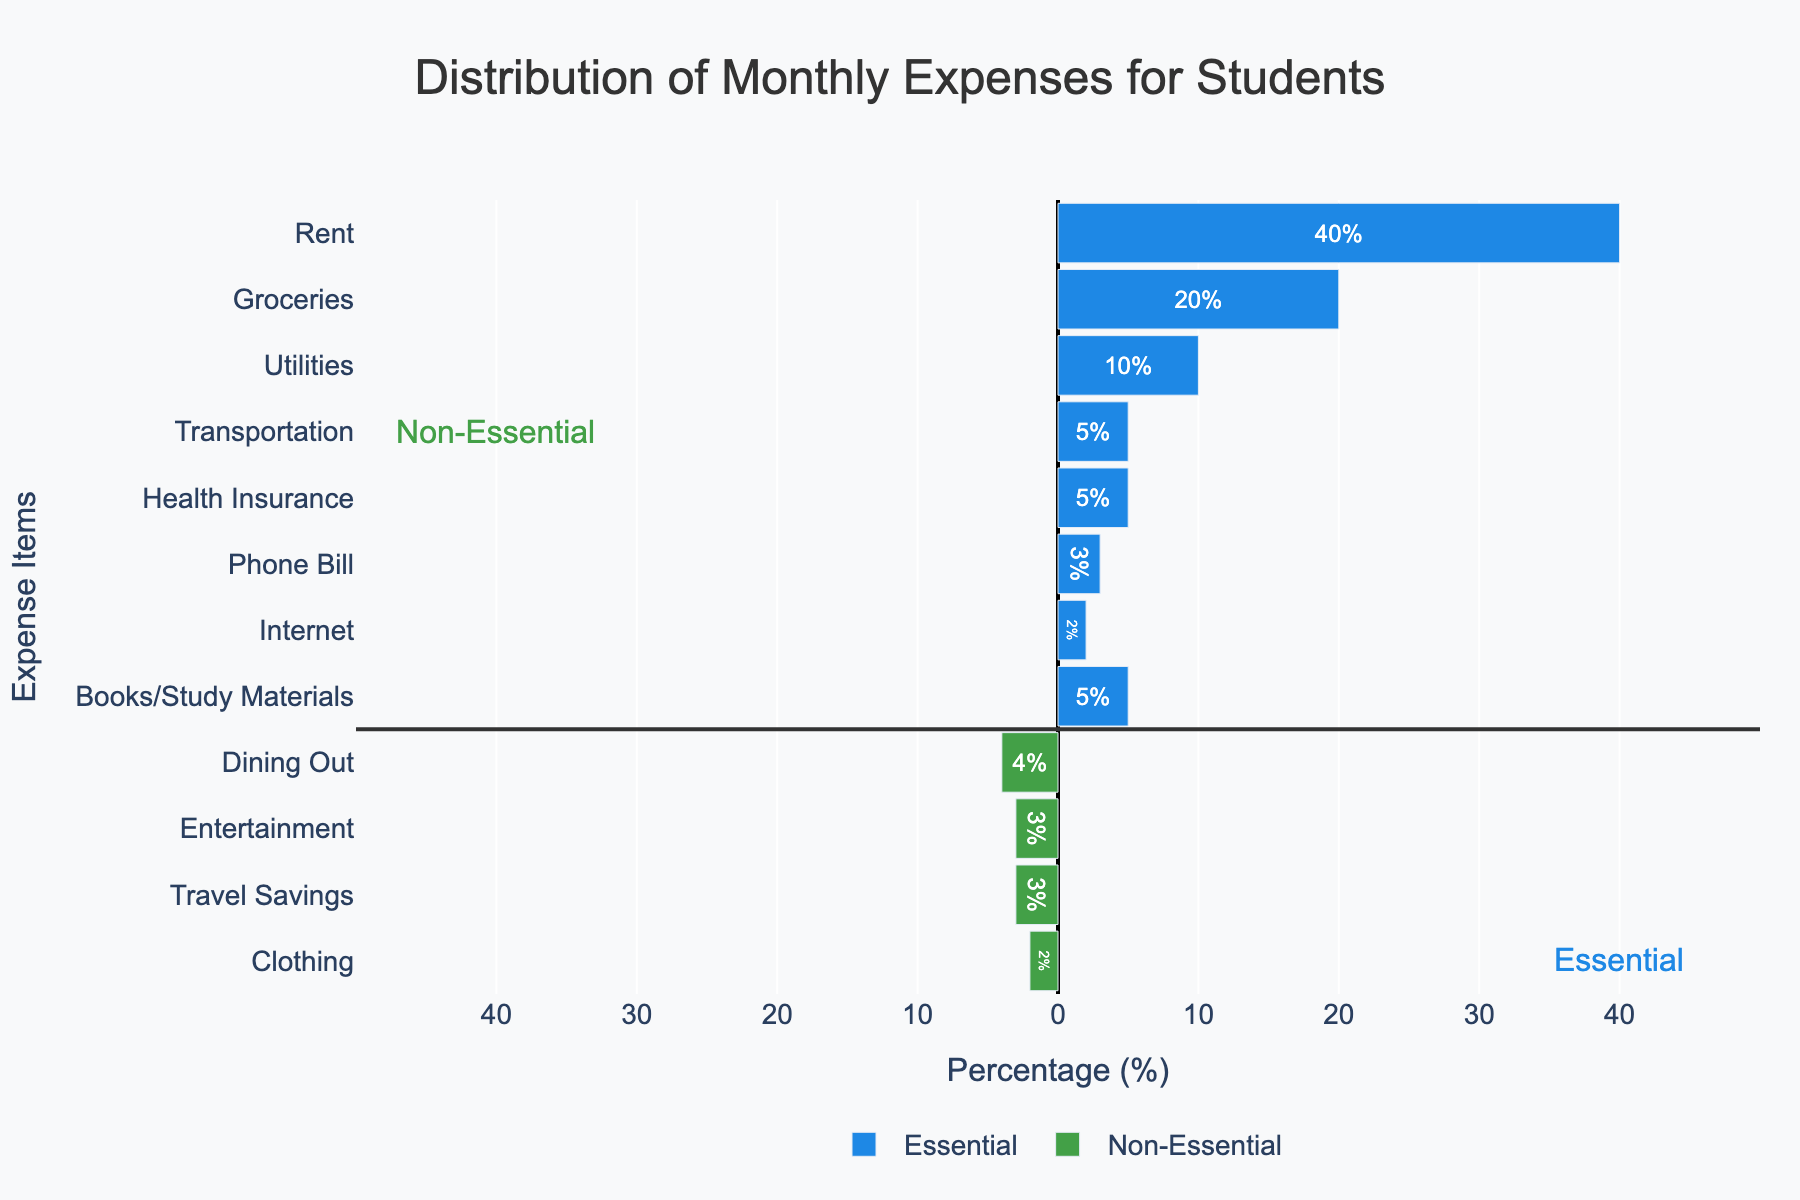What's the total percentage of expenses on essential items? Sum up all the essential items: Rent (40) + Groceries (20) + Utilities (10) + Transportation (5) + Health Insurance (5) + Phone Bill (3) + Internet (2) + Books/Study Materials (5) = 90%
Answer: 90% What's the ratio of non-essential expenses to essential expenses? Calculate the total for non-essential items: Dining Out (4) + Entertainment (3) + Travel Savings (3) + Clothing (2) = 12%. The total for essential items is 90%. The ratio is 12%/90% = 0.1333
Answer: 0.1333 Which expense category has the highest percentage? Compare all percentages and identify the highest value. Rent has the highest percentage at 40%.
Answer: Rent Are the combined percentages of Groceries and Rent more or less than 50%? Sum up Groceries (20) and Rent (40): 20% + 40% = 60%. 60% is more than 50%.
Answer: More What is the percentage difference between Entertainment and Books/Study Materials? Entertainment is 3% and Books/Study Materials are 5%. The difference is 5% - 3% = 2%.
Answer: 2% Which non-essential item has the lowest percentage of expense? Review the percentages of non-essential items: Clothing (2%) has the lowest percentage.
Answer: Clothing What percentage of the rent is covered by the combined expenses of Dining Out, Entertainment, and Travel Savings? Non-essential total: Dining Out (4) + Entertainment (3) + Travel Savings (3) = 10%. Rent is 40%. The percentage is (10/40) * 100 = 25%.
Answer: 25% How many items have a percentage of 5% or more? Review the list and count the items: Rent (40), Groceries (20), Utilities (10), Health Insurance (5), Books/Study Materials (5) - five items have 5% or more.
Answer: 5 